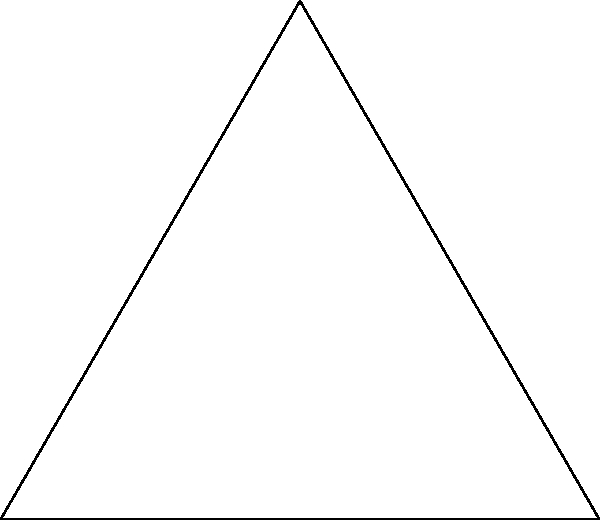In designing a Celtic knot pattern inspired by Yggdrasil, you've created an equilateral triangle as the base structure. If the interior angles of this triangle are all equal, what is the measure of each angle? To determine the measure of each interior angle in an equilateral triangle, we can follow these steps:

1) First, recall that the sum of interior angles in any triangle is always 180°.

2) In an equilateral triangle, all sides are equal in length, and consequently, all angles are equal in measure.

3) Let's denote the measure of each angle as $x°$.

4) Since there are three angles, and they all have the same measure, we can set up the equation:

   $3x = 180°$

5) Solving for $x$:
   
   $x = 180° ÷ 3 = 60°$

Therefore, each interior angle of the equilateral triangle in your Celtic knot pattern measures 60°.
Answer: 60° 